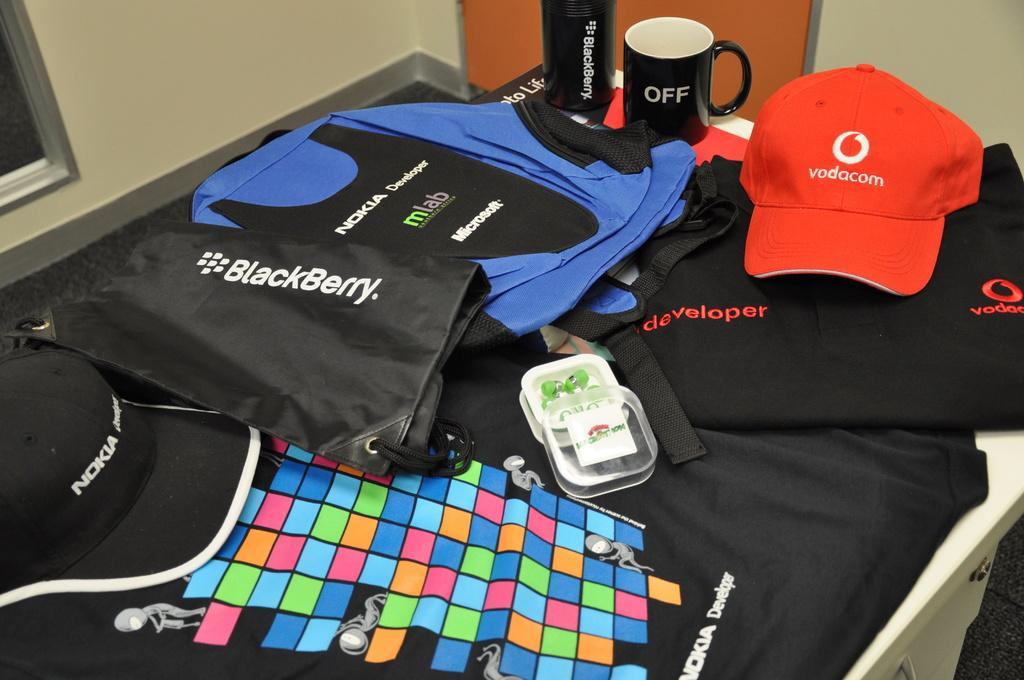How many bags are visible in the image? There are three bags in the image. What other objects can be seen on the table? There is a bottle, a cup, and an earphone visible on the table. How many cups are present in the image? There are two cups in the image. What can be seen in the background of the image? There is a door and a window in the background of the image. Can you tell me how many docks are visible in the image? There are no docks present in the image. What type of self can be seen interacting with the objects in the image? There is no self or person visible in the image; only the objects are present. 